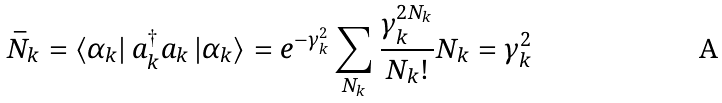Convert formula to latex. <formula><loc_0><loc_0><loc_500><loc_500>\bar { N } _ { k } = \left \langle \alpha _ { k } \right | a _ { k } ^ { \dagger } a _ { k } \left | \alpha _ { k } \right \rangle = e ^ { - \gamma _ { k } ^ { 2 } } \sum _ { N _ { k } } \frac { \gamma _ { k } ^ { 2 N _ { k } } } { N _ { k } ! } N _ { k } = \gamma _ { k } ^ { 2 }</formula> 